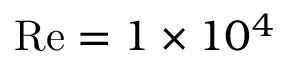Convert formula to latex. <formula><loc_0><loc_0><loc_500><loc_500>R e = 1 \times 1 0 ^ { 4 }</formula> 